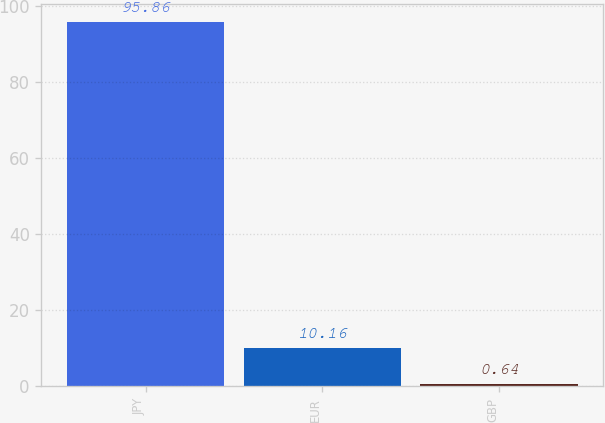Convert chart to OTSL. <chart><loc_0><loc_0><loc_500><loc_500><bar_chart><fcel>JPY<fcel>EUR<fcel>GBP<nl><fcel>95.86<fcel>10.16<fcel>0.64<nl></chart> 